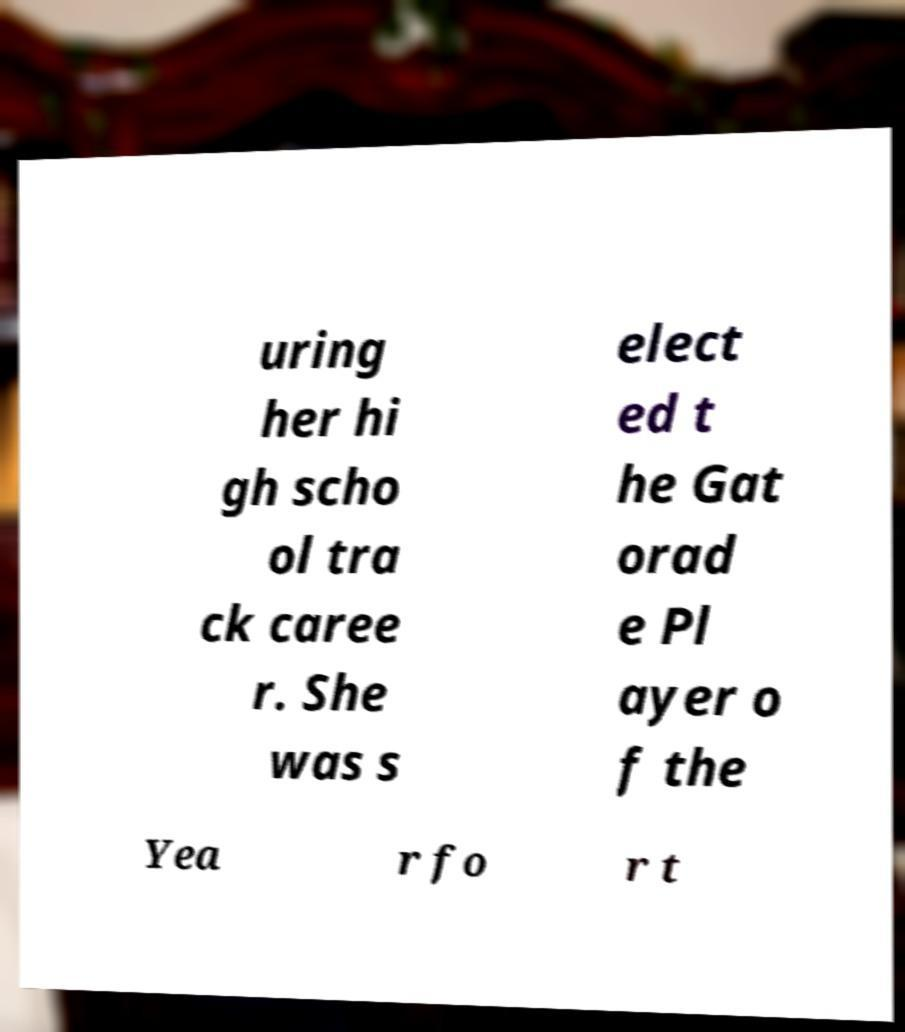Can you accurately transcribe the text from the provided image for me? uring her hi gh scho ol tra ck caree r. She was s elect ed t he Gat orad e Pl ayer o f the Yea r fo r t 